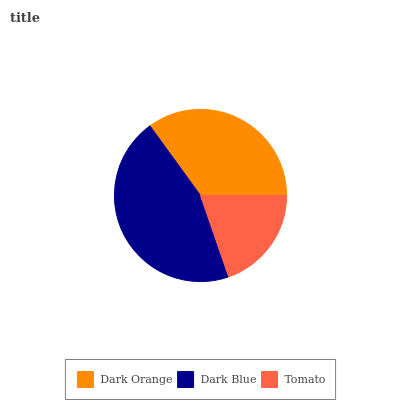Is Tomato the minimum?
Answer yes or no. Yes. Is Dark Blue the maximum?
Answer yes or no. Yes. Is Dark Blue the minimum?
Answer yes or no. No. Is Tomato the maximum?
Answer yes or no. No. Is Dark Blue greater than Tomato?
Answer yes or no. Yes. Is Tomato less than Dark Blue?
Answer yes or no. Yes. Is Tomato greater than Dark Blue?
Answer yes or no. No. Is Dark Blue less than Tomato?
Answer yes or no. No. Is Dark Orange the high median?
Answer yes or no. Yes. Is Dark Orange the low median?
Answer yes or no. Yes. Is Dark Blue the high median?
Answer yes or no. No. Is Tomato the low median?
Answer yes or no. No. 